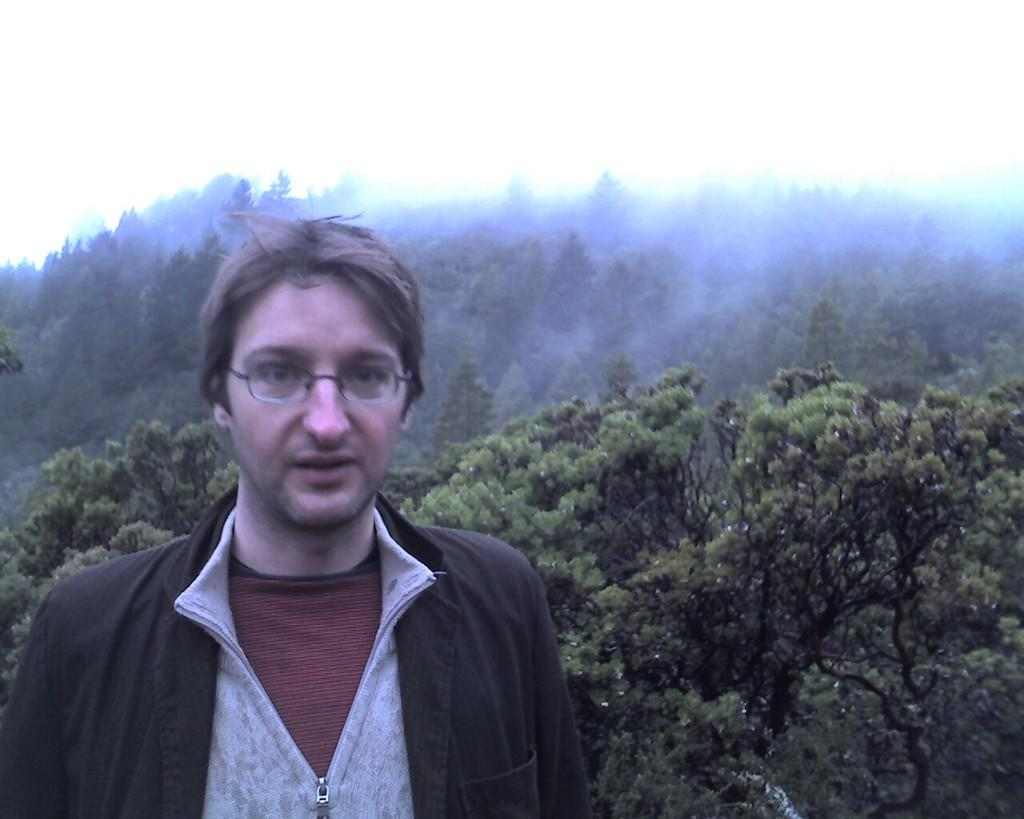What is the main subject of the image? There is a person standing in the image. What can be seen in the background of the image? There are many trees visible behind the person. What type of pipe is being played by the person in the image? There is no pipe present in the image; the person is simply standing. What direction is the zephyr blowing in the image? There is no mention of a zephyr or any wind in the image; it only shows a person standing and trees in the background. 